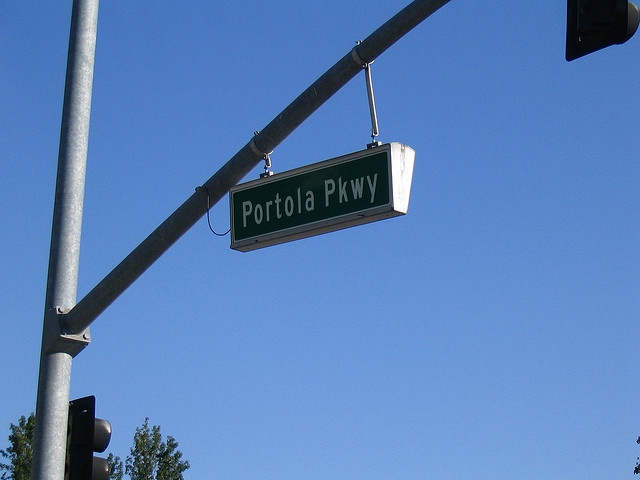Describe the objects in this image and their specific colors. I can see traffic light in blue, black, navy, and gray tones and traffic light in blue, black, gray, navy, and darkgray tones in this image. 